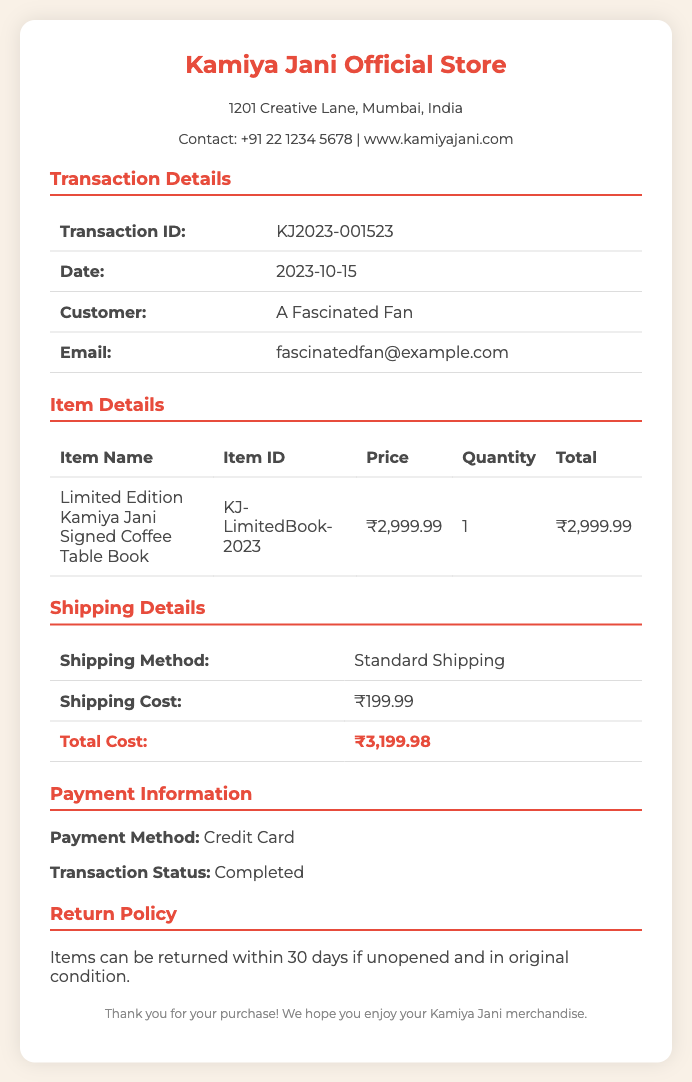What is the transaction ID? The transaction ID is a unique identifier for the purchase in the document, shown under Transaction Details.
Answer: KJ2023-001523 What is the date of the transaction? The date of the transaction is listed under Transaction Details in the document.
Answer: 2023-10-15 What is the price of the Limited Edition Kamiya Jani Signed Coffee Table Book? The price is specified in the Item Details section of the document.
Answer: ₹2,999.99 What is the shipping cost? The shipping cost is detailed in the Shipping Details section, indicating the additional charge for delivery.
Answer: ₹199.99 What is the total cost of the purchase? The total cost is the sum of the item price and shipping cost, calculated in the document.
Answer: ₹3,199.98 What payment method was used for the purchase? The payment method is mentioned in the Payment Information section of the document.
Answer: Credit Card How many items were purchased? The quantity of items purchased is specified in the Item Details table of the document.
Answer: 1 What is the return policy duration? The return policy duration is mentioned in the Return Policy section of the document.
Answer: 30 days What is the customer's email address? The customer's email address is indicated under Transaction Details in the document.
Answer: fascinatedfan@example.com 